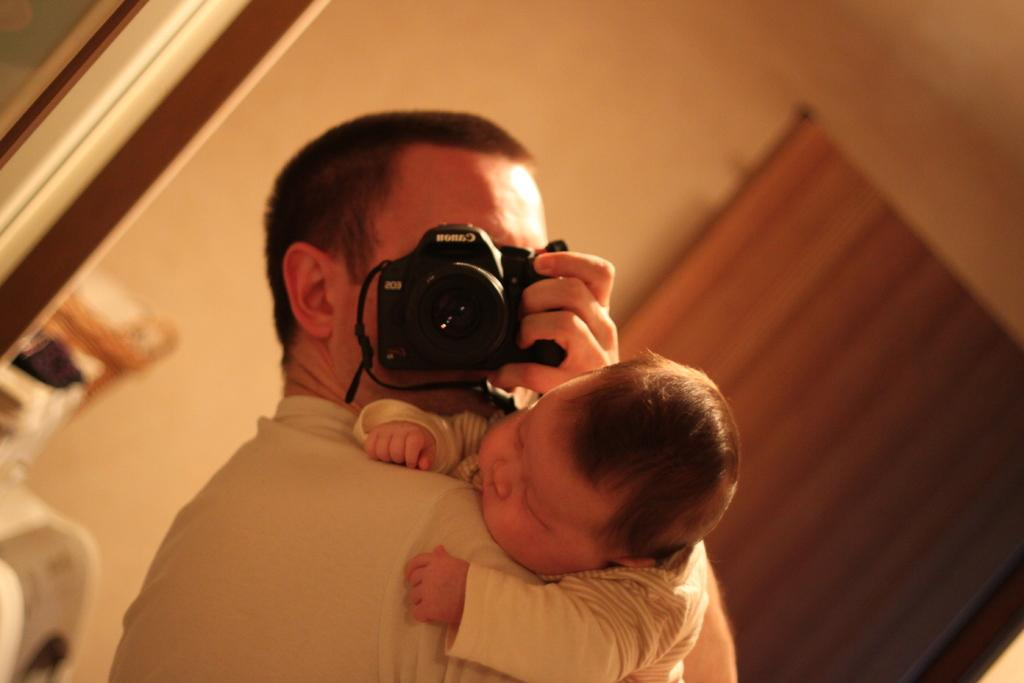What is the main subject of the image? There is a person in the image. What is the person holding in one hand? The person is holding a baby in one hand. What is the person holding in the other hand? The person is holding a camera in the other hand. What type of hammer is the person using to shake the mist in the image? There is no hammer, shaking, or mist present in the image. 